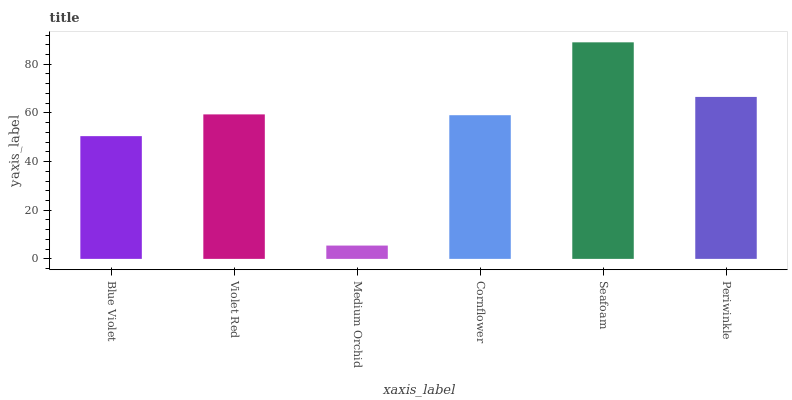Is Medium Orchid the minimum?
Answer yes or no. Yes. Is Seafoam the maximum?
Answer yes or no. Yes. Is Violet Red the minimum?
Answer yes or no. No. Is Violet Red the maximum?
Answer yes or no. No. Is Violet Red greater than Blue Violet?
Answer yes or no. Yes. Is Blue Violet less than Violet Red?
Answer yes or no. Yes. Is Blue Violet greater than Violet Red?
Answer yes or no. No. Is Violet Red less than Blue Violet?
Answer yes or no. No. Is Violet Red the high median?
Answer yes or no. Yes. Is Cornflower the low median?
Answer yes or no. Yes. Is Blue Violet the high median?
Answer yes or no. No. Is Violet Red the low median?
Answer yes or no. No. 